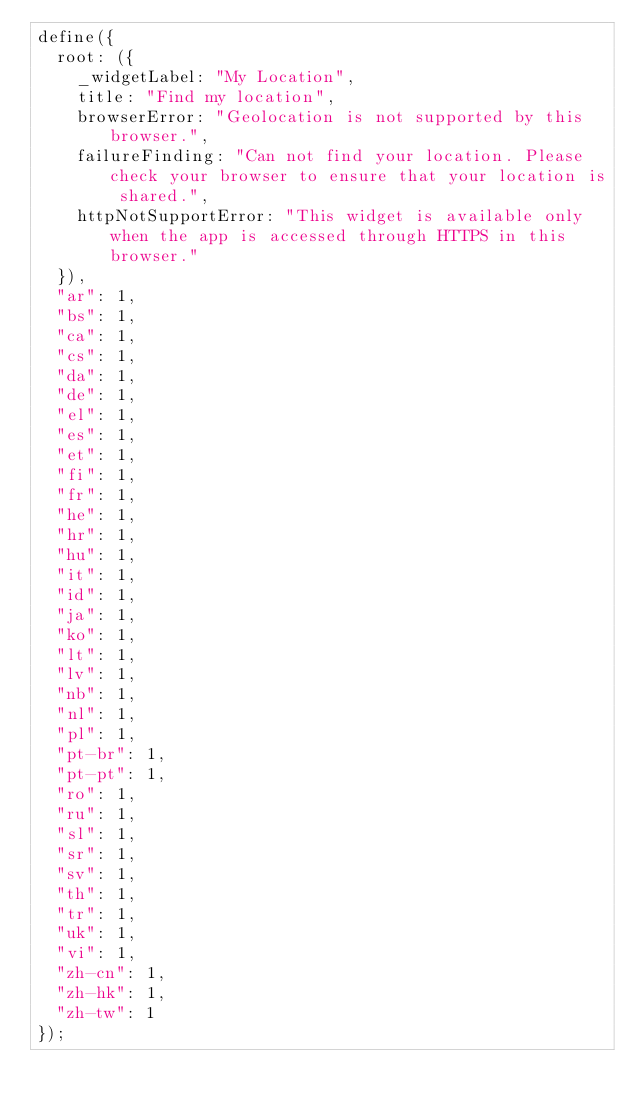Convert code to text. <code><loc_0><loc_0><loc_500><loc_500><_JavaScript_>define({
  root: ({
    _widgetLabel: "My Location",
    title: "Find my location",
    browserError: "Geolocation is not supported by this browser.",
    failureFinding: "Can not find your location. Please check your browser to ensure that your location is shared.",
    httpNotSupportError: "This widget is available only when the app is accessed through HTTPS in this browser."
  }),
  "ar": 1,
  "bs": 1,
  "ca": 1,
  "cs": 1,
  "da": 1,
  "de": 1,
  "el": 1,
  "es": 1,
  "et": 1,
  "fi": 1,
  "fr": 1,
  "he": 1,
  "hr": 1,
  "hu": 1,
  "it": 1,
  "id": 1,
  "ja": 1,
  "ko": 1,
  "lt": 1,
  "lv": 1,
  "nb": 1,
  "nl": 1,
  "pl": 1,
  "pt-br": 1,
  "pt-pt": 1,
  "ro": 1,
  "ru": 1,
  "sl": 1,
  "sr": 1,
  "sv": 1,
  "th": 1,
  "tr": 1,
  "uk": 1,
  "vi": 1,
  "zh-cn": 1,
  "zh-hk": 1,
  "zh-tw": 1
});</code> 